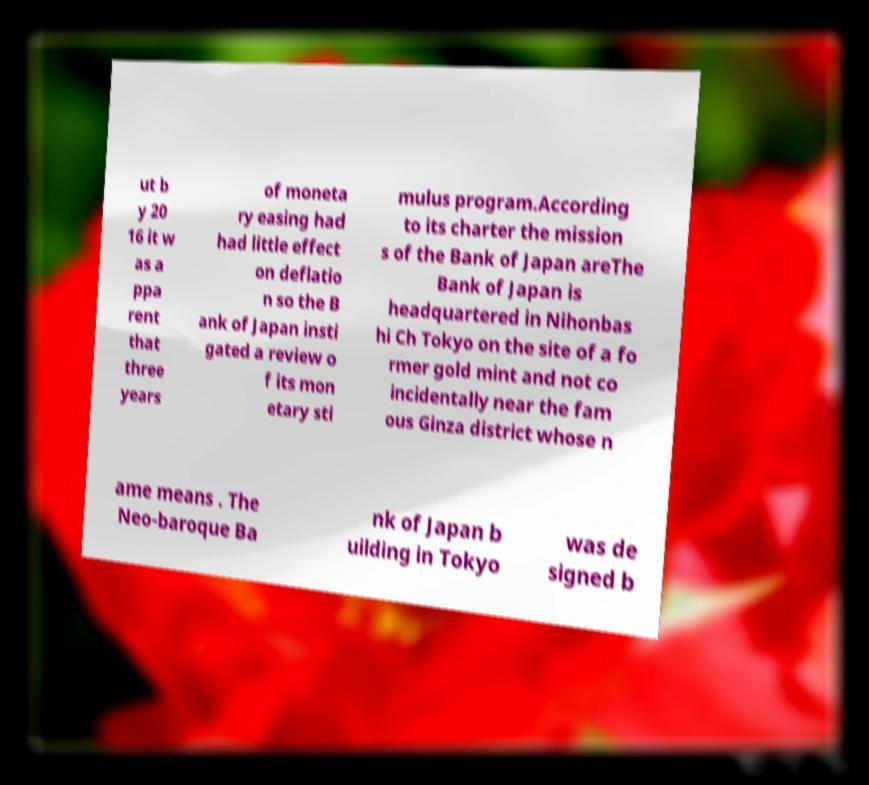Can you read and provide the text displayed in the image?This photo seems to have some interesting text. Can you extract and type it out for me? ut b y 20 16 it w as a ppa rent that three years of moneta ry easing had had little effect on deflatio n so the B ank of Japan insti gated a review o f its mon etary sti mulus program.According to its charter the mission s of the Bank of Japan areThe Bank of Japan is headquartered in Nihonbas hi Ch Tokyo on the site of a fo rmer gold mint and not co incidentally near the fam ous Ginza district whose n ame means . The Neo-baroque Ba nk of Japan b uilding in Tokyo was de signed b 